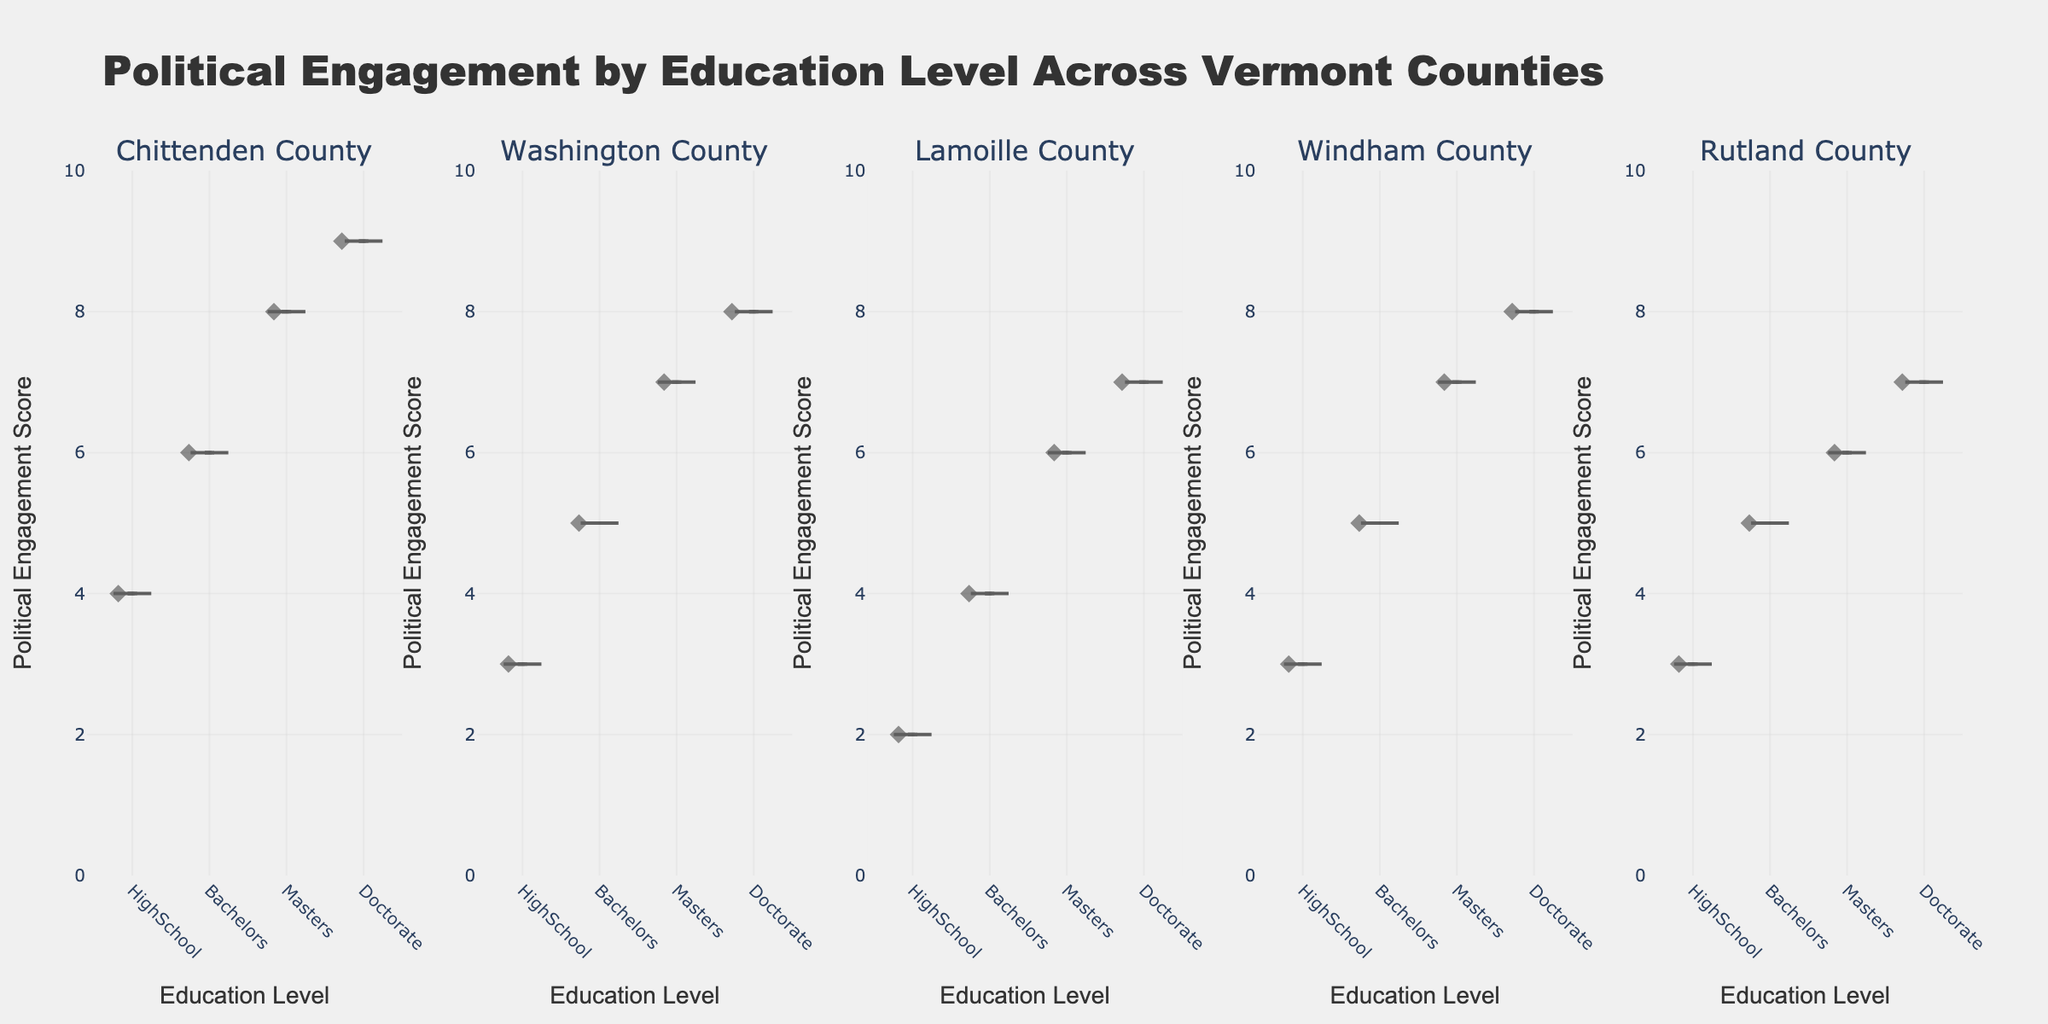Which district has the highest median political engagement score for Doctorate holders? To determine this, look at the median (the line inside the box) on the violin plots for Doctorate holders across all districts.
Answer: Chittenden County What is the range of political engagement scores for Bachelors degree holders in Chittenden County? The range of a dataset is the difference between the maximum and minimum values. Look at the extremes of the Bachelors degree holders' violin plot in Chittenden County.
Answer: 6-9 Which education level shows the greatest spread of political engagement scores in Rutland County? The spread of a dataset can be visualized by the width and length of the violin plot. Find the plot with the widest distribution for Rutland County.
Answer: Bachelors In which district do HighSchool graduates have the lowest political engagement score? Examine the minimum values of the HighSchool graduates' violin plots across all districts and identify the lowest.
Answer: Lamoille County How many education levels show relatively equal political engagement scores across Washington County? Examine the heights and distributions of the violin plots for Washington County. Determine how many of them are similar in terms of engagement scores.
Answer: 3 Which district shows the most noticeable increase in political engagement scores as education level increases? Compare the trends in political engagement scores (mean lines) across education levels for all districts. Look for the district with the most significant upward trend.
Answer: Chittenden County Do Masters degree holders in Windham County have higher median political engagement scores than in Lamoille County? Compare the median (line in the box) values of Masters degree holders between Windham and Lamoille Counties.
Answer: Yes For which education level in Washington County is the interquartile range (IQR) of political engagement scores the largest? The IQR is the range between the first quartile (25th percentile) and the third quartile (75th percentile). Look at the width of the box inside the violin plots for Washington County.
Answer: Masters 